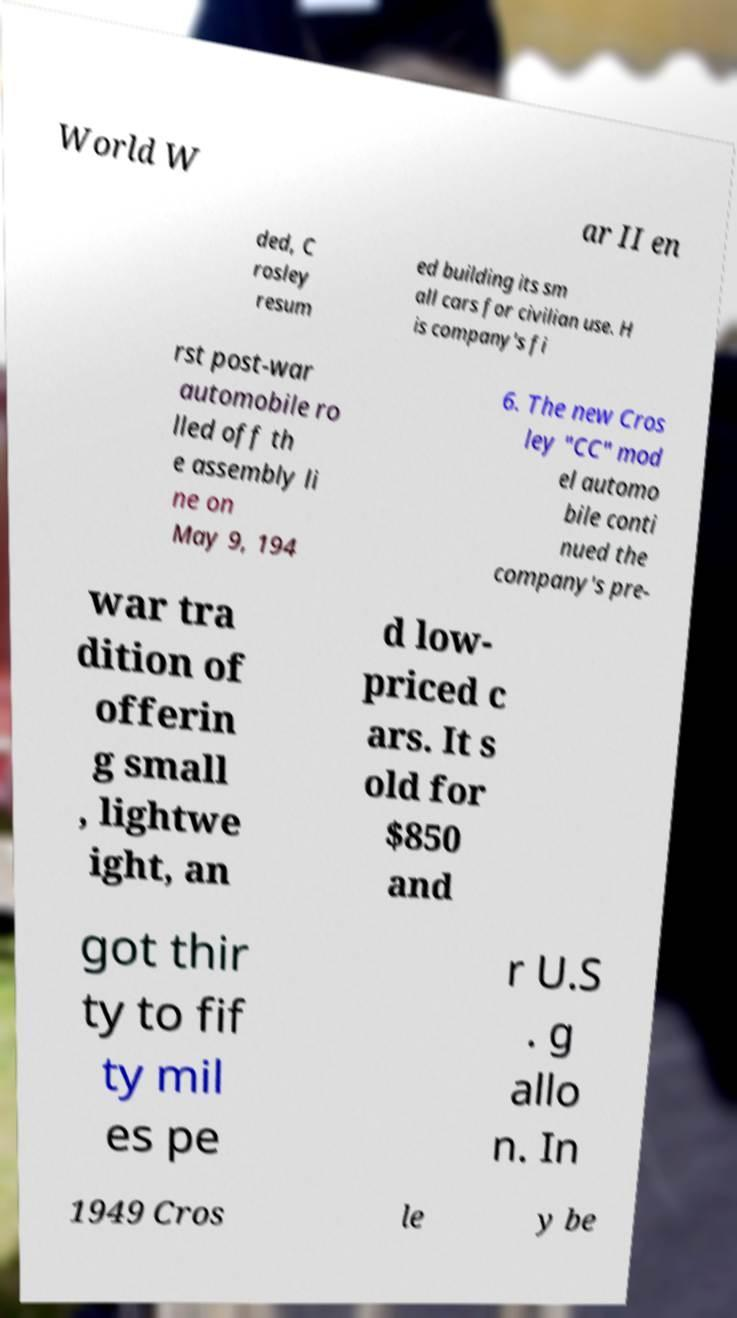Could you extract and type out the text from this image? World W ar II en ded, C rosley resum ed building its sm all cars for civilian use. H is company's fi rst post-war automobile ro lled off th e assembly li ne on May 9, 194 6. The new Cros ley "CC" mod el automo bile conti nued the company's pre- war tra dition of offerin g small , lightwe ight, an d low- priced c ars. It s old for $850 and got thir ty to fif ty mil es pe r U.S . g allo n. In 1949 Cros le y be 